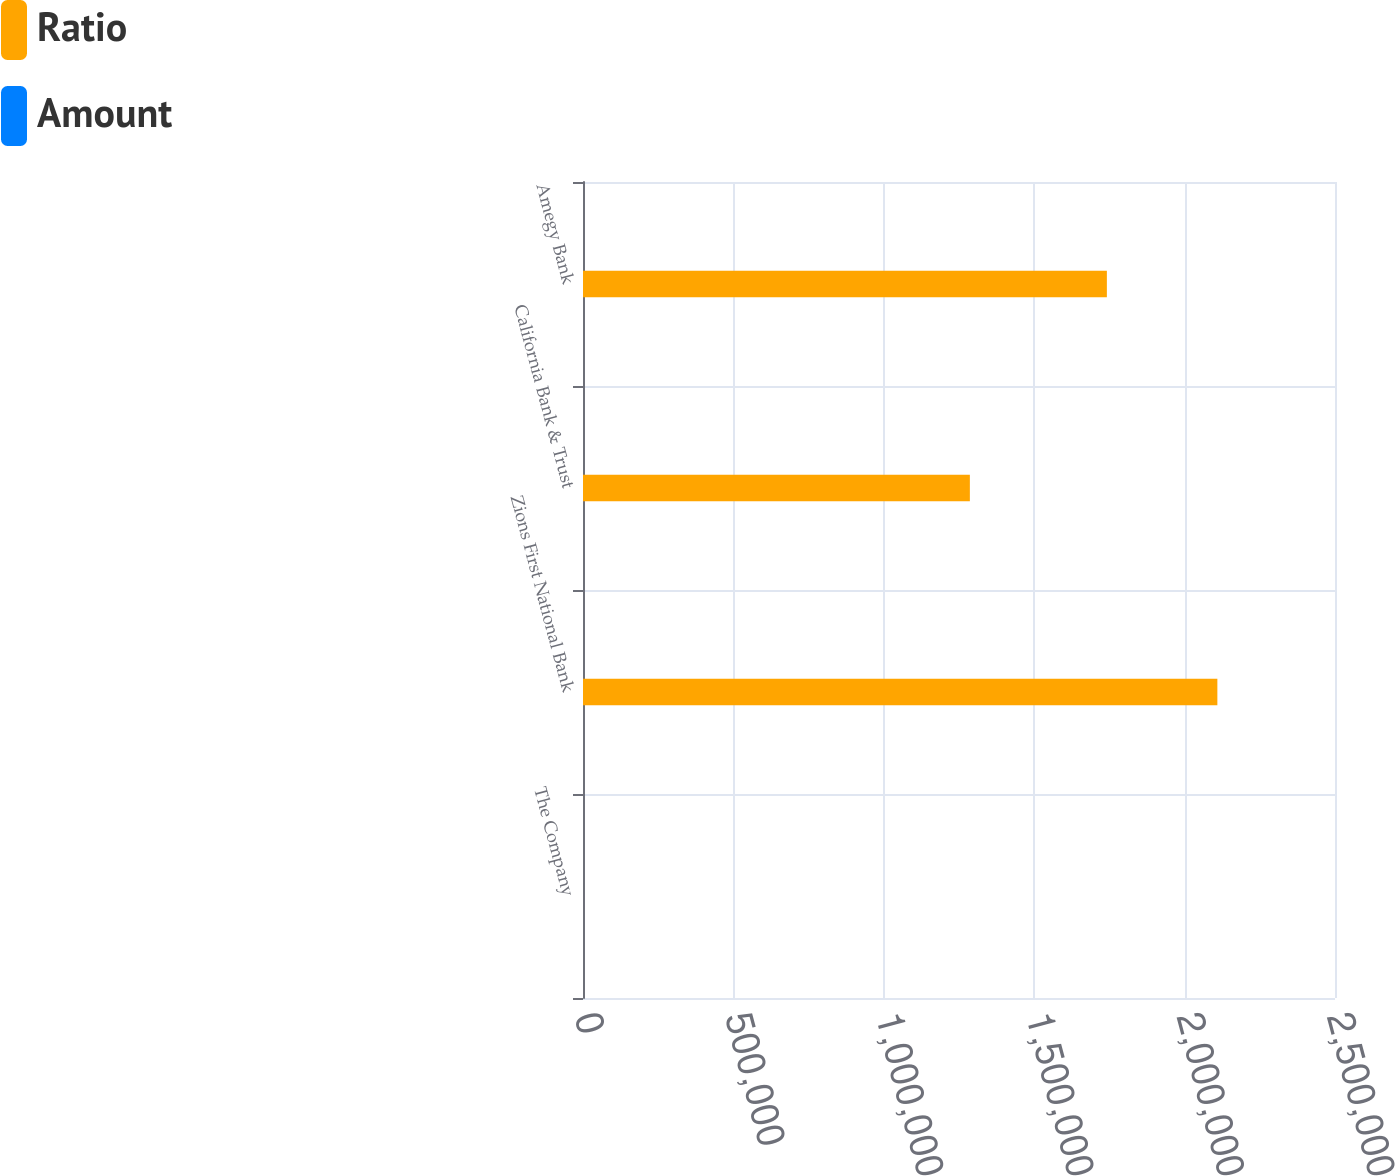Convert chart to OTSL. <chart><loc_0><loc_0><loc_500><loc_500><stacked_bar_chart><ecel><fcel>The Company<fcel>Zions First National Bank<fcel>California Bank & Trust<fcel>Amegy Bank<nl><fcel>Ratio<fcel>16.27<fcel>2.1089e+06<fcel>1.2861e+06<fcel>1.74159e+06<nl><fcel>Amount<fcel>16.27<fcel>15.27<fcel>14.18<fcel>14.09<nl></chart> 